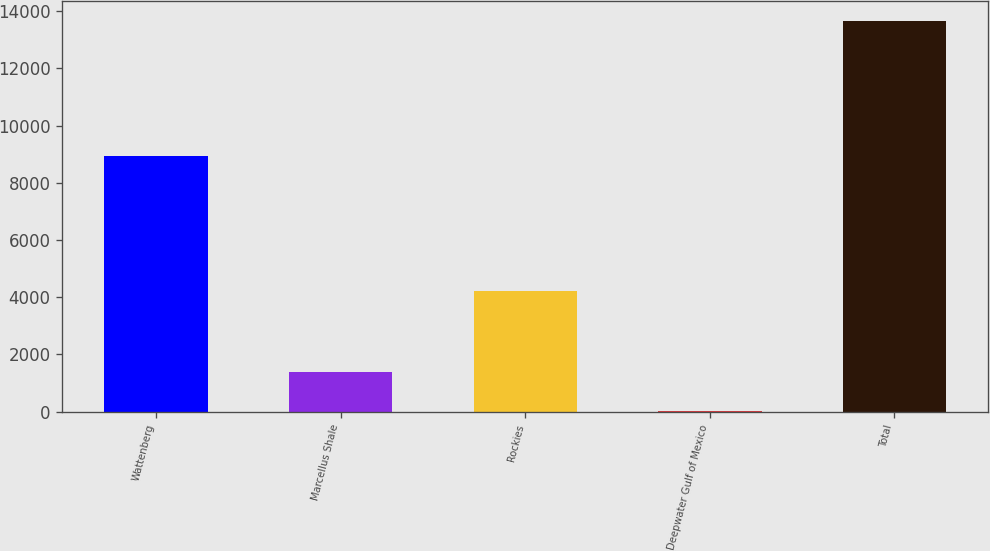Convert chart. <chart><loc_0><loc_0><loc_500><loc_500><bar_chart><fcel>Wattenberg<fcel>Marcellus Shale<fcel>Rockies<fcel>Deepwater Gulf of Mexico<fcel>Total<nl><fcel>8954<fcel>1376<fcel>4210<fcel>11<fcel>13661<nl></chart> 